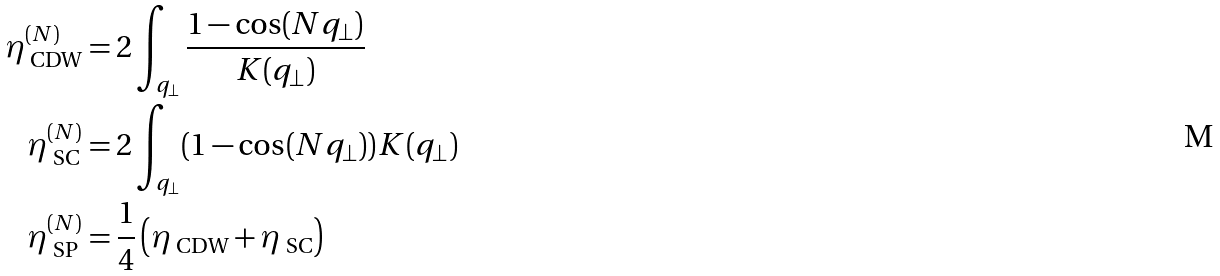Convert formula to latex. <formula><loc_0><loc_0><loc_500><loc_500>\eta _ { \text { CDW} } ^ { ( N ) } & = 2 \int _ { q _ { \perp } } \frac { 1 - \cos ( N q _ { \perp } ) } { K ( q _ { \perp } ) } \\ \eta _ { \text { SC} } ^ { ( N ) } & = 2 \int _ { q _ { \perp } } ( 1 - \cos ( N q _ { \perp } ) ) K ( q _ { \perp } ) \\ \eta _ { \text { SP} } ^ { ( N ) } & = \frac { 1 } { 4 } \left ( \eta _ { \text { CDW} } + \eta _ { \text { SC} } \right )</formula> 